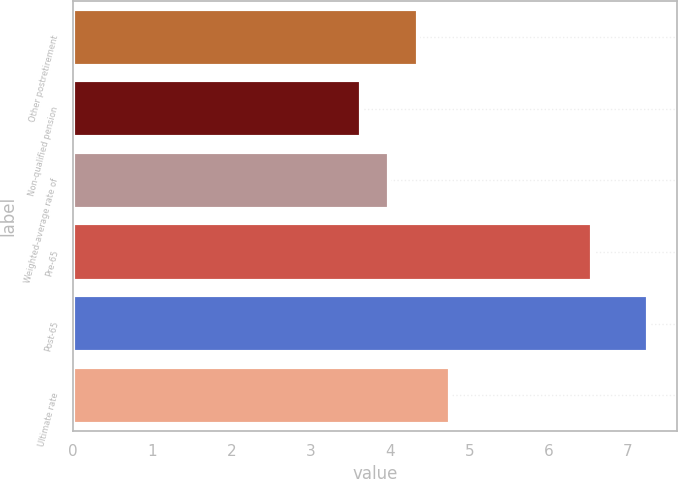Convert chart. <chart><loc_0><loc_0><loc_500><loc_500><bar_chart><fcel>Other postretirement<fcel>Non-qualified pension<fcel>Weighted-average rate of<fcel>Pre-65<fcel>Post-65<fcel>Ultimate rate<nl><fcel>4.35<fcel>3.63<fcel>3.99<fcel>6.55<fcel>7.25<fcel>4.75<nl></chart> 